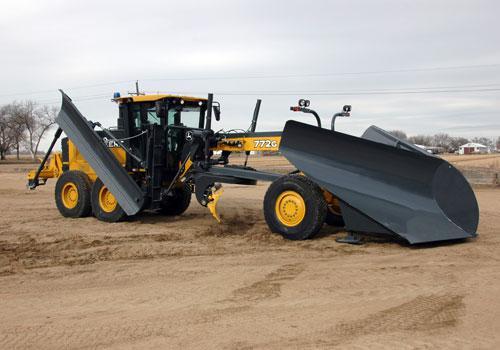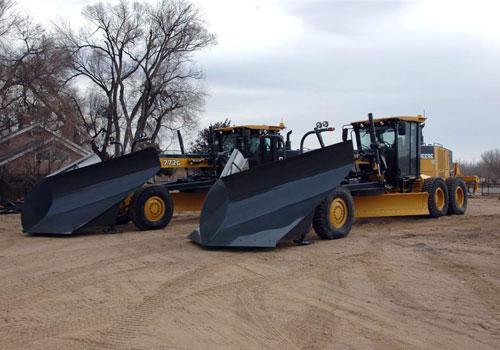The first image is the image on the left, the second image is the image on the right. Analyze the images presented: Is the assertion "Right image shows at least one yellow tractor with plow on a dirt ground without snow." valid? Answer yes or no. Yes. 